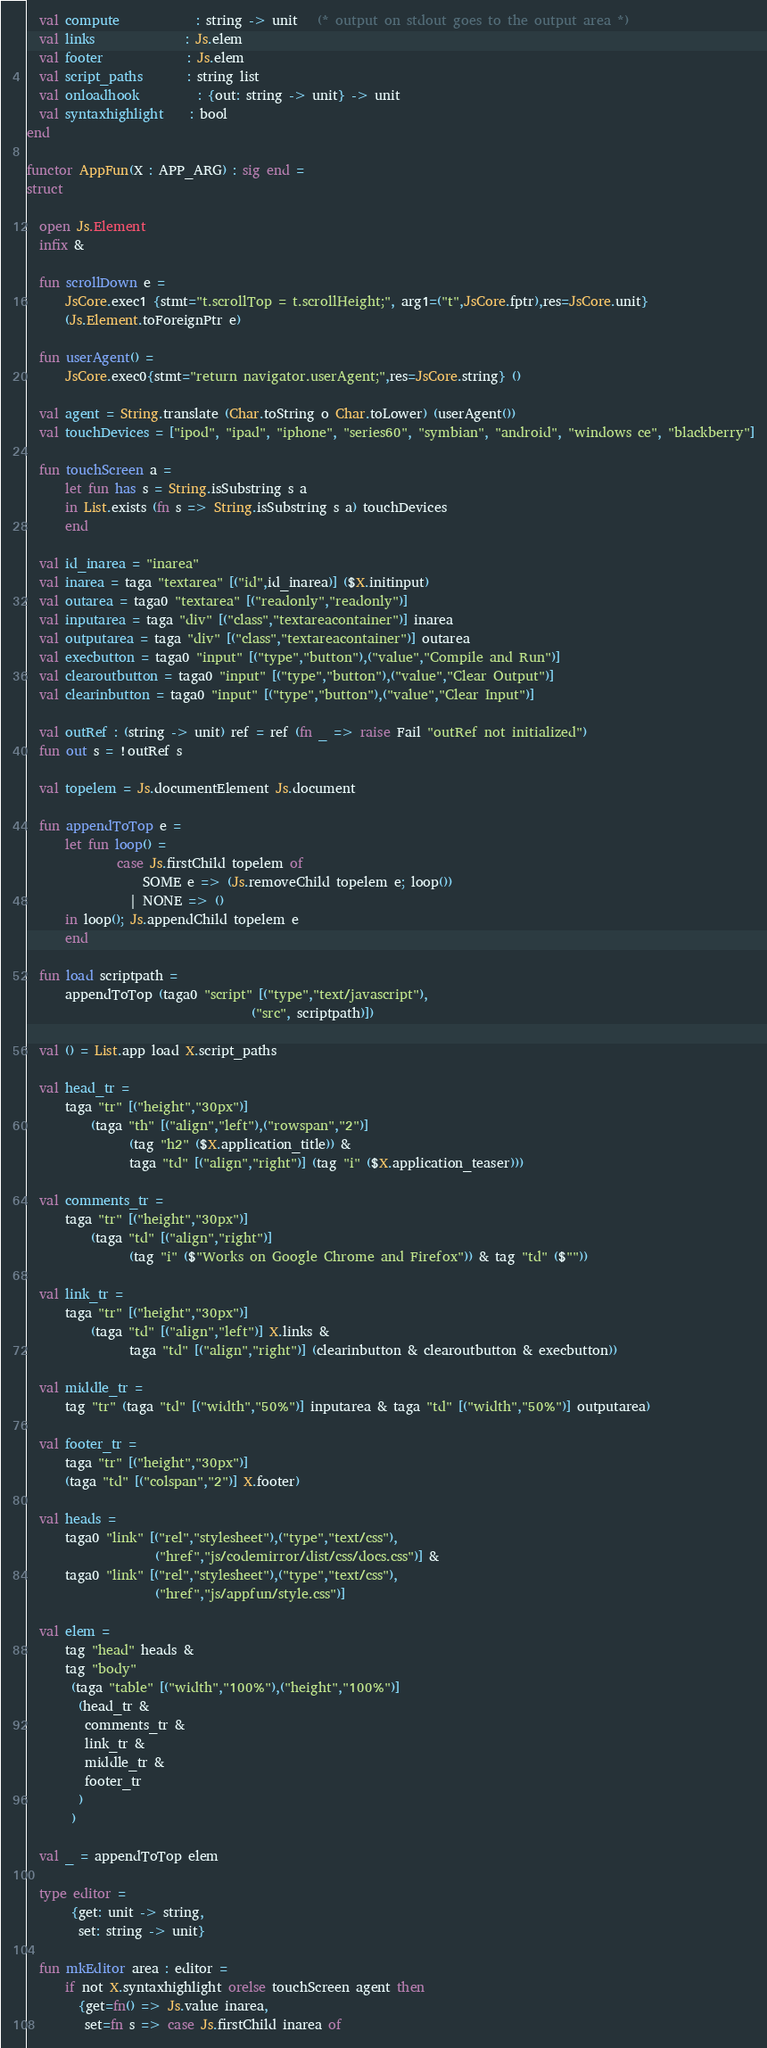<code> <loc_0><loc_0><loc_500><loc_500><_SML_>  val compute            : string -> unit   (* output on stdout goes to the output area *)
  val links              : Js.elem
  val footer             : Js.elem
  val script_paths       : string list
  val onloadhook         : {out: string -> unit} -> unit
  val syntaxhighlight    : bool
end

functor AppFun(X : APP_ARG) : sig end =
struct

  open Js.Element
  infix &

  fun scrollDown e = 
      JsCore.exec1 {stmt="t.scrollTop = t.scrollHeight;", arg1=("t",JsCore.fptr),res=JsCore.unit}
      (Js.Element.toForeignPtr e)

  fun userAgent() =
      JsCore.exec0{stmt="return navigator.userAgent;",res=JsCore.string} ()

  val agent = String.translate (Char.toString o Char.toLower) (userAgent())
  val touchDevices = ["ipod", "ipad", "iphone", "series60", "symbian", "android", "windows ce", "blackberry"]

  fun touchScreen a =
      let fun has s = String.isSubstring s a
      in List.exists (fn s => String.isSubstring s a) touchDevices
      end

  val id_inarea = "inarea"
  val inarea = taga "textarea" [("id",id_inarea)] ($X.initinput)
  val outarea = taga0 "textarea" [("readonly","readonly")]
  val inputarea = taga "div" [("class","textareacontainer")] inarea          
  val outputarea = taga "div" [("class","textareacontainer")] outarea
  val execbutton = taga0 "input" [("type","button"),("value","Compile and Run")]
  val clearoutbutton = taga0 "input" [("type","button"),("value","Clear Output")]
  val clearinbutton = taga0 "input" [("type","button"),("value","Clear Input")]

  val outRef : (string -> unit) ref = ref (fn _ => raise Fail "outRef not initialized")
  fun out s = !outRef s

  val topelem = Js.documentElement Js.document

  fun appendToTop e = 
      let fun loop() =
              case Js.firstChild topelem of
                  SOME e => (Js.removeChild topelem e; loop())
                | NONE => ()
      in loop(); Js.appendChild topelem e
      end

  fun load scriptpath =
      appendToTop (taga0 "script" [("type","text/javascript"), 
                                   ("src", scriptpath)])

  val () = List.app load X.script_paths

  val head_tr =
      taga "tr" [("height","30px")]
          (taga "th" [("align","left"),("rowspan","2")]
                (tag "h2" ($X.application_title)) & 
                taga "td" [("align","right")] (tag "i" ($X.application_teaser)))      

  val comments_tr =
      taga "tr" [("height","30px")]
          (taga "td" [("align","right")]
                (tag "i" ($"Works on Google Chrome and Firefox")) & tag "td" ($""))

  val link_tr =
      taga "tr" [("height","30px")]
          (taga "td" [("align","left")] X.links &
                taga "td" [("align","right")] (clearinbutton & clearoutbutton & execbutton))

  val middle_tr =
      tag "tr" (taga "td" [("width","50%")] inputarea & taga "td" [("width","50%")] outputarea)

  val footer_tr =
      taga "tr" [("height","30px")]
      (taga "td" [("colspan","2")] X.footer)

  val heads =
      taga0 "link" [("rel","stylesheet"),("type","text/css"),
                    ("href","js/codemirror/dist/css/docs.css")] &
      taga0 "link" [("rel","stylesheet"),("type","text/css"),
                    ("href","js/appfun/style.css")]            

  val elem =
      tag "head" heads &
      tag "body"
       (taga "table" [("width","100%"),("height","100%")]
        (head_tr &
         comments_tr &
         link_tr &         
         middle_tr &
         footer_tr
        )
       )
 
  val _ = appendToTop elem

  type editor = 
       {get: unit -> string,
        set: string -> unit}

  fun mkEditor area : editor =
      if not X.syntaxhighlight orelse touchScreen agent then
        {get=fn() => Js.value inarea,
         set=fn s => case Js.firstChild inarea of</code> 